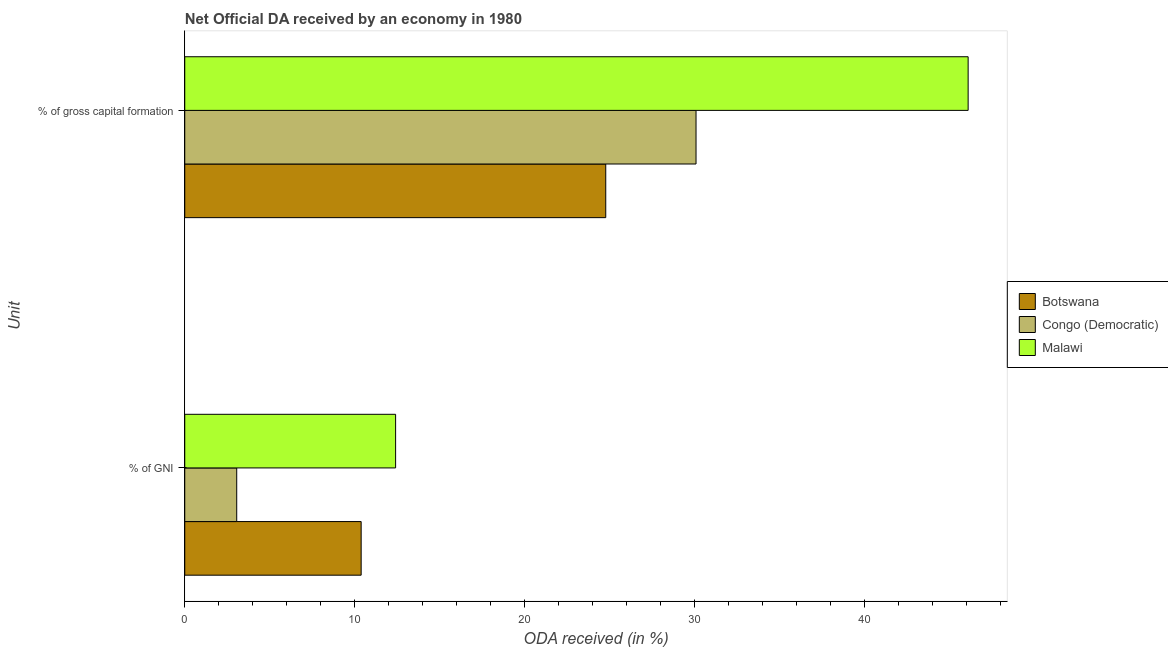How many different coloured bars are there?
Your answer should be very brief. 3. Are the number of bars per tick equal to the number of legend labels?
Give a very brief answer. Yes. Are the number of bars on each tick of the Y-axis equal?
Provide a short and direct response. Yes. How many bars are there on the 1st tick from the top?
Offer a terse response. 3. What is the label of the 1st group of bars from the top?
Offer a terse response. % of gross capital formation. What is the oda received as percentage of gni in Botswana?
Provide a succinct answer. 10.38. Across all countries, what is the maximum oda received as percentage of gross capital formation?
Offer a very short reply. 46.1. Across all countries, what is the minimum oda received as percentage of gross capital formation?
Keep it short and to the point. 24.77. In which country was the oda received as percentage of gni maximum?
Offer a very short reply. Malawi. In which country was the oda received as percentage of gni minimum?
Your response must be concise. Congo (Democratic). What is the total oda received as percentage of gross capital formation in the graph?
Ensure brevity in your answer.  100.96. What is the difference between the oda received as percentage of gross capital formation in Congo (Democratic) and that in Botswana?
Offer a very short reply. 5.31. What is the difference between the oda received as percentage of gni in Congo (Democratic) and the oda received as percentage of gross capital formation in Botswana?
Your answer should be compact. -21.72. What is the average oda received as percentage of gni per country?
Make the answer very short. 8.62. What is the difference between the oda received as percentage of gross capital formation and oda received as percentage of gni in Congo (Democratic)?
Offer a terse response. 27.03. In how many countries, is the oda received as percentage of gni greater than 26 %?
Offer a terse response. 0. What is the ratio of the oda received as percentage of gross capital formation in Malawi to that in Congo (Democratic)?
Your answer should be very brief. 1.53. In how many countries, is the oda received as percentage of gross capital formation greater than the average oda received as percentage of gross capital formation taken over all countries?
Your answer should be compact. 1. What does the 2nd bar from the top in % of gross capital formation represents?
Your response must be concise. Congo (Democratic). What does the 1st bar from the bottom in % of gross capital formation represents?
Provide a succinct answer. Botswana. How many bars are there?
Make the answer very short. 6. How many countries are there in the graph?
Your answer should be compact. 3. What is the difference between two consecutive major ticks on the X-axis?
Provide a short and direct response. 10. Are the values on the major ticks of X-axis written in scientific E-notation?
Provide a short and direct response. No. Does the graph contain any zero values?
Give a very brief answer. No. Does the graph contain grids?
Provide a succinct answer. No. How many legend labels are there?
Give a very brief answer. 3. What is the title of the graph?
Ensure brevity in your answer.  Net Official DA received by an economy in 1980. Does "United Kingdom" appear as one of the legend labels in the graph?
Provide a short and direct response. No. What is the label or title of the X-axis?
Provide a succinct answer. ODA received (in %). What is the label or title of the Y-axis?
Give a very brief answer. Unit. What is the ODA received (in %) in Botswana in % of GNI?
Offer a very short reply. 10.38. What is the ODA received (in %) of Congo (Democratic) in % of GNI?
Offer a terse response. 3.06. What is the ODA received (in %) in Malawi in % of GNI?
Your answer should be very brief. 12.41. What is the ODA received (in %) in Botswana in % of gross capital formation?
Provide a succinct answer. 24.77. What is the ODA received (in %) in Congo (Democratic) in % of gross capital formation?
Your answer should be very brief. 30.09. What is the ODA received (in %) in Malawi in % of gross capital formation?
Give a very brief answer. 46.1. Across all Unit, what is the maximum ODA received (in %) in Botswana?
Offer a terse response. 24.77. Across all Unit, what is the maximum ODA received (in %) in Congo (Democratic)?
Offer a terse response. 30.09. Across all Unit, what is the maximum ODA received (in %) in Malawi?
Make the answer very short. 46.1. Across all Unit, what is the minimum ODA received (in %) in Botswana?
Offer a terse response. 10.38. Across all Unit, what is the minimum ODA received (in %) in Congo (Democratic)?
Your answer should be compact. 3.06. Across all Unit, what is the minimum ODA received (in %) of Malawi?
Your response must be concise. 12.41. What is the total ODA received (in %) in Botswana in the graph?
Your response must be concise. 35.16. What is the total ODA received (in %) in Congo (Democratic) in the graph?
Keep it short and to the point. 33.15. What is the total ODA received (in %) of Malawi in the graph?
Your answer should be very brief. 58.51. What is the difference between the ODA received (in %) of Botswana in % of GNI and that in % of gross capital formation?
Offer a very short reply. -14.39. What is the difference between the ODA received (in %) in Congo (Democratic) in % of GNI and that in % of gross capital formation?
Provide a succinct answer. -27.03. What is the difference between the ODA received (in %) of Malawi in % of GNI and that in % of gross capital formation?
Your answer should be compact. -33.69. What is the difference between the ODA received (in %) in Botswana in % of GNI and the ODA received (in %) in Congo (Democratic) in % of gross capital formation?
Make the answer very short. -19.71. What is the difference between the ODA received (in %) in Botswana in % of GNI and the ODA received (in %) in Malawi in % of gross capital formation?
Your response must be concise. -35.72. What is the difference between the ODA received (in %) of Congo (Democratic) in % of GNI and the ODA received (in %) of Malawi in % of gross capital formation?
Your response must be concise. -43.04. What is the average ODA received (in %) in Botswana per Unit?
Keep it short and to the point. 17.58. What is the average ODA received (in %) in Congo (Democratic) per Unit?
Your response must be concise. 16.57. What is the average ODA received (in %) of Malawi per Unit?
Your answer should be very brief. 29.25. What is the difference between the ODA received (in %) in Botswana and ODA received (in %) in Congo (Democratic) in % of GNI?
Your answer should be very brief. 7.32. What is the difference between the ODA received (in %) of Botswana and ODA received (in %) of Malawi in % of GNI?
Keep it short and to the point. -2.03. What is the difference between the ODA received (in %) of Congo (Democratic) and ODA received (in %) of Malawi in % of GNI?
Make the answer very short. -9.35. What is the difference between the ODA received (in %) in Botswana and ODA received (in %) in Congo (Democratic) in % of gross capital formation?
Provide a short and direct response. -5.31. What is the difference between the ODA received (in %) of Botswana and ODA received (in %) of Malawi in % of gross capital formation?
Your answer should be very brief. -21.33. What is the difference between the ODA received (in %) in Congo (Democratic) and ODA received (in %) in Malawi in % of gross capital formation?
Your response must be concise. -16.01. What is the ratio of the ODA received (in %) in Botswana in % of GNI to that in % of gross capital formation?
Offer a very short reply. 0.42. What is the ratio of the ODA received (in %) of Congo (Democratic) in % of GNI to that in % of gross capital formation?
Give a very brief answer. 0.1. What is the ratio of the ODA received (in %) of Malawi in % of GNI to that in % of gross capital formation?
Your answer should be compact. 0.27. What is the difference between the highest and the second highest ODA received (in %) in Botswana?
Keep it short and to the point. 14.39. What is the difference between the highest and the second highest ODA received (in %) of Congo (Democratic)?
Keep it short and to the point. 27.03. What is the difference between the highest and the second highest ODA received (in %) in Malawi?
Your answer should be very brief. 33.69. What is the difference between the highest and the lowest ODA received (in %) in Botswana?
Keep it short and to the point. 14.39. What is the difference between the highest and the lowest ODA received (in %) in Congo (Democratic)?
Ensure brevity in your answer.  27.03. What is the difference between the highest and the lowest ODA received (in %) of Malawi?
Give a very brief answer. 33.69. 